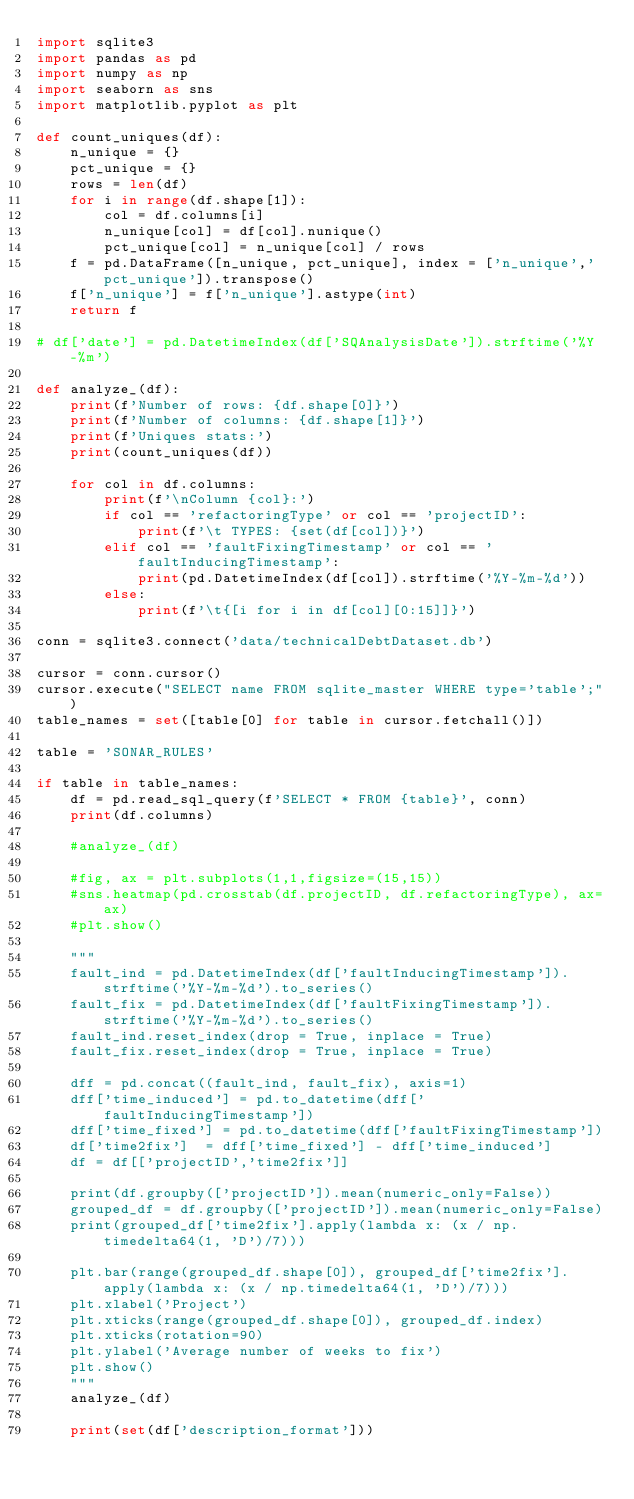Convert code to text. <code><loc_0><loc_0><loc_500><loc_500><_Python_>import sqlite3
import pandas as pd
import numpy as np
import seaborn as sns
import matplotlib.pyplot as plt

def count_uniques(df):
    n_unique = {}
    pct_unique = {}
    rows = len(df)
    for i in range(df.shape[1]):
        col = df.columns[i]
        n_unique[col] = df[col].nunique()
        pct_unique[col] = n_unique[col] / rows
    f = pd.DataFrame([n_unique, pct_unique], index = ['n_unique','pct_unique']).transpose()
    f['n_unique'] = f['n_unique'].astype(int)
    return f

# df['date'] = pd.DatetimeIndex(df['SQAnalysisDate']).strftime('%Y-%m')

def analyze_(df):
    print(f'Number of rows: {df.shape[0]}')
    print(f'Number of columns: {df.shape[1]}')
    print(f'Uniques stats:')
    print(count_uniques(df))
    
    for col in df.columns:
        print(f'\nColumn {col}:')
        if col == 'refactoringType' or col == 'projectID':
            print(f'\t TYPES: {set(df[col])}')
        elif col == 'faultFixingTimestamp' or col == 'faultInducingTimestamp': 
            print(pd.DatetimeIndex(df[col]).strftime('%Y-%m-%d'))
        else: 
            print(f'\t{[i for i in df[col][0:15]]}')

conn = sqlite3.connect('data/technicalDebtDataset.db')

cursor = conn.cursor()
cursor.execute("SELECT name FROM sqlite_master WHERE type='table';")
table_names = set([table[0] for table in cursor.fetchall()])

table = 'SONAR_RULES'

if table in table_names:
    df = pd.read_sql_query(f'SELECT * FROM {table}', conn)
    print(df.columns)

    #analyze_(df)

    #fig, ax = plt.subplots(1,1,figsize=(15,15))
    #sns.heatmap(pd.crosstab(df.projectID, df.refactoringType), ax=ax)
    #plt.show()

    """
    fault_ind = pd.DatetimeIndex(df['faultInducingTimestamp']).strftime('%Y-%m-%d').to_series()
    fault_fix = pd.DatetimeIndex(df['faultFixingTimestamp']).strftime('%Y-%m-%d').to_series()
    fault_ind.reset_index(drop = True, inplace = True)
    fault_fix.reset_index(drop = True, inplace = True)

    dff = pd.concat((fault_ind, fault_fix), axis=1)
    dff['time_induced'] = pd.to_datetime(dff['faultInducingTimestamp'])
    dff['time_fixed'] = pd.to_datetime(dff['faultFixingTimestamp'])
    df['time2fix']  = dff['time_fixed'] - dff['time_induced']
    df = df[['projectID','time2fix']]
    
    print(df.groupby(['projectID']).mean(numeric_only=False))
    grouped_df = df.groupby(['projectID']).mean(numeric_only=False)
    print(grouped_df['time2fix'].apply(lambda x: (x / np.timedelta64(1, 'D')/7)))

    plt.bar(range(grouped_df.shape[0]), grouped_df['time2fix'].apply(lambda x: (x / np.timedelta64(1, 'D')/7)))
    plt.xlabel('Project')
    plt.xticks(range(grouped_df.shape[0]), grouped_df.index)
    plt.xticks(rotation=90)
    plt.ylabel('Average number of weeks to fix')
    plt.show()
    """
    analyze_(df)

    print(set(df['description_format']))



</code> 